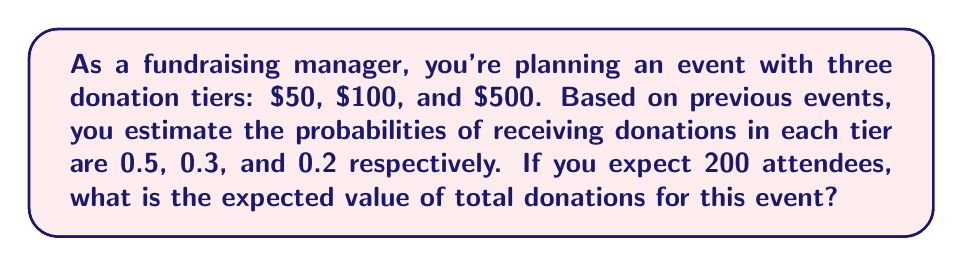What is the answer to this math problem? To solve this problem, we'll use the concept of expected value. The expected value is calculated by multiplying each possible outcome by its probability and then summing these products.

Step 1: Define the random variable and its probability distribution.
Let X be the donation amount from a single attendee.
P(X = $50) = 0.5
P(X = $100) = 0.3
P(X = $500) = 0.2

Step 2: Calculate the expected value for a single attendee.
$$E(X) = \sum_{i=1}^{n} x_i \cdot P(X = x_i)$$
$$E(X) = 50 \cdot 0.5 + 100 \cdot 0.3 + 500 \cdot 0.2$$
$$E(X) = 25 + 30 + 100 = $155$$

Step 3: Calculate the expected total donations for 200 attendees.
Since the expected value is linear, we can multiply the expected value for a single attendee by the number of attendees.

$$E(\text{Total Donations}) = 200 \cdot E(X) = 200 \cdot $155 = $31,000$$

Therefore, the expected value of total donations for this event is $31,000.
Answer: $31,000 